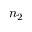<formula> <loc_0><loc_0><loc_500><loc_500>n _ { 2 }</formula> 